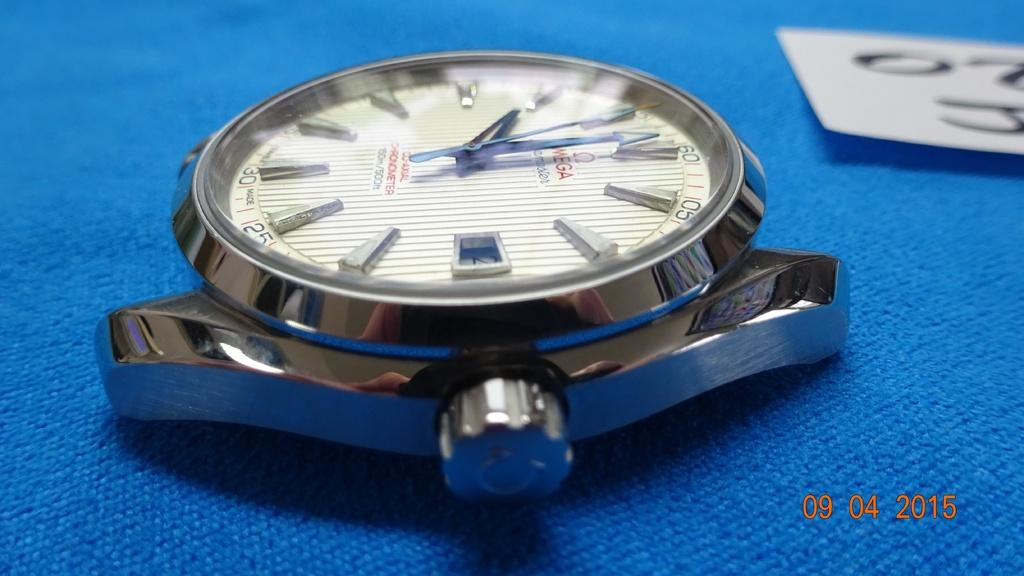<image>
Describe the image concisely. A photo of a strapless watch face that was taken on September 4, 2015. 